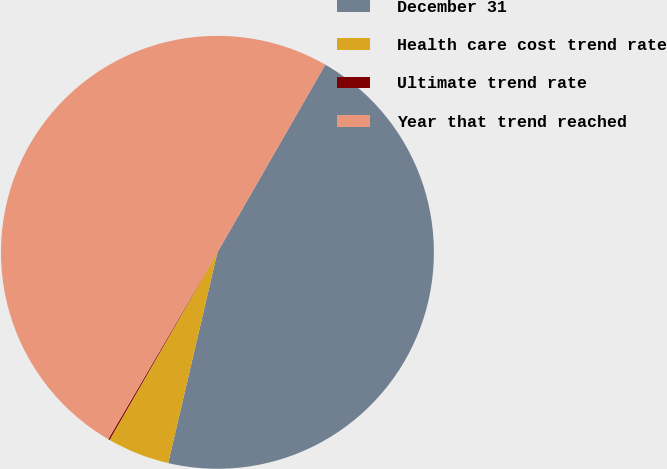Convert chart. <chart><loc_0><loc_0><loc_500><loc_500><pie_chart><fcel>December 31<fcel>Health care cost trend rate<fcel>Ultimate trend rate<fcel>Year that trend reached<nl><fcel>45.35%<fcel>4.65%<fcel>0.11%<fcel>49.89%<nl></chart> 